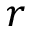Convert formula to latex. <formula><loc_0><loc_0><loc_500><loc_500>r</formula> 